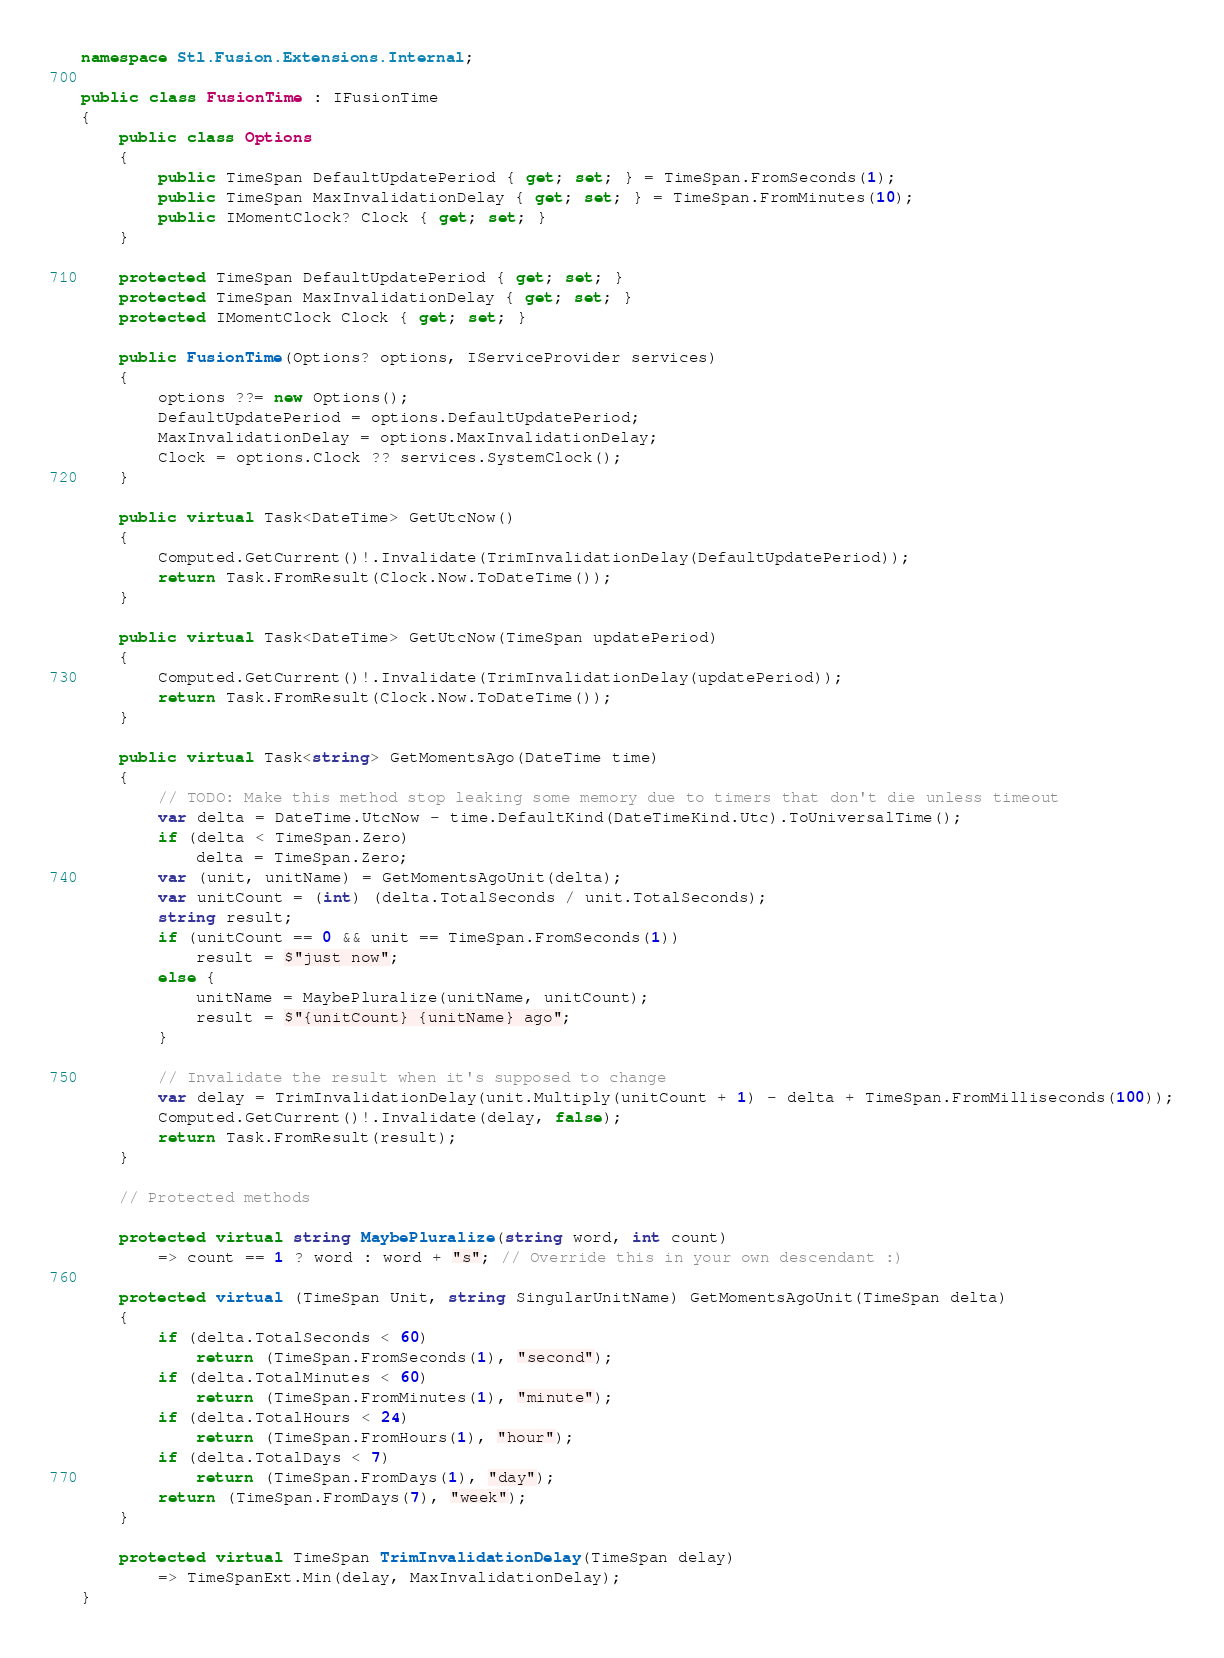Convert code to text. <code><loc_0><loc_0><loc_500><loc_500><_C#_>namespace Stl.Fusion.Extensions.Internal;

public class FusionTime : IFusionTime
{
    public class Options
    {
        public TimeSpan DefaultUpdatePeriod { get; set; } = TimeSpan.FromSeconds(1);
        public TimeSpan MaxInvalidationDelay { get; set; } = TimeSpan.FromMinutes(10);
        public IMomentClock? Clock { get; set; }
    }

    protected TimeSpan DefaultUpdatePeriod { get; set; }
    protected TimeSpan MaxInvalidationDelay { get; set; }
    protected IMomentClock Clock { get; set; }

    public FusionTime(Options? options, IServiceProvider services)
    {
        options ??= new Options();
        DefaultUpdatePeriod = options.DefaultUpdatePeriod;
        MaxInvalidationDelay = options.MaxInvalidationDelay;
        Clock = options.Clock ?? services.SystemClock();
    }

    public virtual Task<DateTime> GetUtcNow()
    {
        Computed.GetCurrent()!.Invalidate(TrimInvalidationDelay(DefaultUpdatePeriod));
        return Task.FromResult(Clock.Now.ToDateTime());
    }

    public virtual Task<DateTime> GetUtcNow(TimeSpan updatePeriod)
    {
        Computed.GetCurrent()!.Invalidate(TrimInvalidationDelay(updatePeriod));
        return Task.FromResult(Clock.Now.ToDateTime());
    }

    public virtual Task<string> GetMomentsAgo(DateTime time)
    {
        // TODO: Make this method stop leaking some memory due to timers that don't die unless timeout
        var delta = DateTime.UtcNow - time.DefaultKind(DateTimeKind.Utc).ToUniversalTime();
        if (delta < TimeSpan.Zero)
            delta = TimeSpan.Zero;
        var (unit, unitName) = GetMomentsAgoUnit(delta);
        var unitCount = (int) (delta.TotalSeconds / unit.TotalSeconds);
        string result;
        if (unitCount == 0 && unit == TimeSpan.FromSeconds(1))
            result = $"just now";
        else {
            unitName = MaybePluralize(unitName, unitCount);
            result = $"{unitCount} {unitName} ago";
        }

        // Invalidate the result when it's supposed to change
        var delay = TrimInvalidationDelay(unit.Multiply(unitCount + 1) - delta + TimeSpan.FromMilliseconds(100));
        Computed.GetCurrent()!.Invalidate(delay, false);
        return Task.FromResult(result);
    }

    // Protected methods

    protected virtual string MaybePluralize(string word, int count)
        => count == 1 ? word : word + "s"; // Override this in your own descendant :)

    protected virtual (TimeSpan Unit, string SingularUnitName) GetMomentsAgoUnit(TimeSpan delta)
    {
        if (delta.TotalSeconds < 60)
            return (TimeSpan.FromSeconds(1), "second");
        if (delta.TotalMinutes < 60)
            return (TimeSpan.FromMinutes(1), "minute");
        if (delta.TotalHours < 24)
            return (TimeSpan.FromHours(1), "hour");
        if (delta.TotalDays < 7)
            return (TimeSpan.FromDays(1), "day");
        return (TimeSpan.FromDays(7), "week");
    }

    protected virtual TimeSpan TrimInvalidationDelay(TimeSpan delay)
        => TimeSpanExt.Min(delay, MaxInvalidationDelay);
}
</code> 